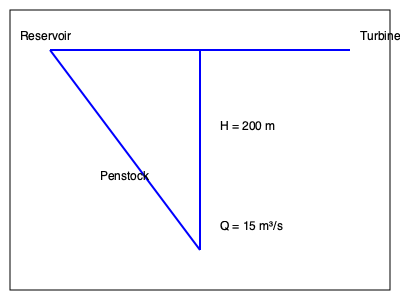Given the hydroelectric system diagram, calculate the potential energy output in megawatts (MW) if the system efficiency is 85%. Assume the gravitational acceleration is 9.8 m/s². To calculate the potential energy output of the hydroelectric system, we'll follow these steps:

1. Identify the given parameters:
   - Height difference (H) = 200 m
   - Water flow rate (Q) = 15 m³/s
   - System efficiency (η) = 85% = 0.85
   - Gravitational acceleration (g) = 9.8 m/s²

2. Use the formula for hydroelectric power:
   $P = η × ρ × g × Q × H$
   Where:
   P = Power output (W)
   η = System efficiency
   ρ = Density of water (1000 kg/m³)
   g = Gravitational acceleration (9.8 m/s²)
   Q = Water flow rate (m³/s)
   H = Height difference (m)

3. Substitute the values into the formula:
   $P = 0.85 × 1000 × 9.8 × 15 × 200$

4. Calculate the result:
   $P = 24,990,000 W = 24.99 MW$

5. Round to two decimal places:
   $P ≈ 25.00 MW$
Answer: 25.00 MW 